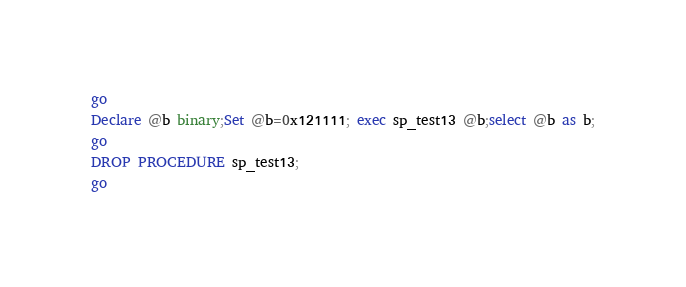<code> <loc_0><loc_0><loc_500><loc_500><_SQL_>go
Declare @b binary;Set @b=0x121111; exec sp_test13 @b;select @b as b;
go
DROP PROCEDURE sp_test13;
go
</code> 